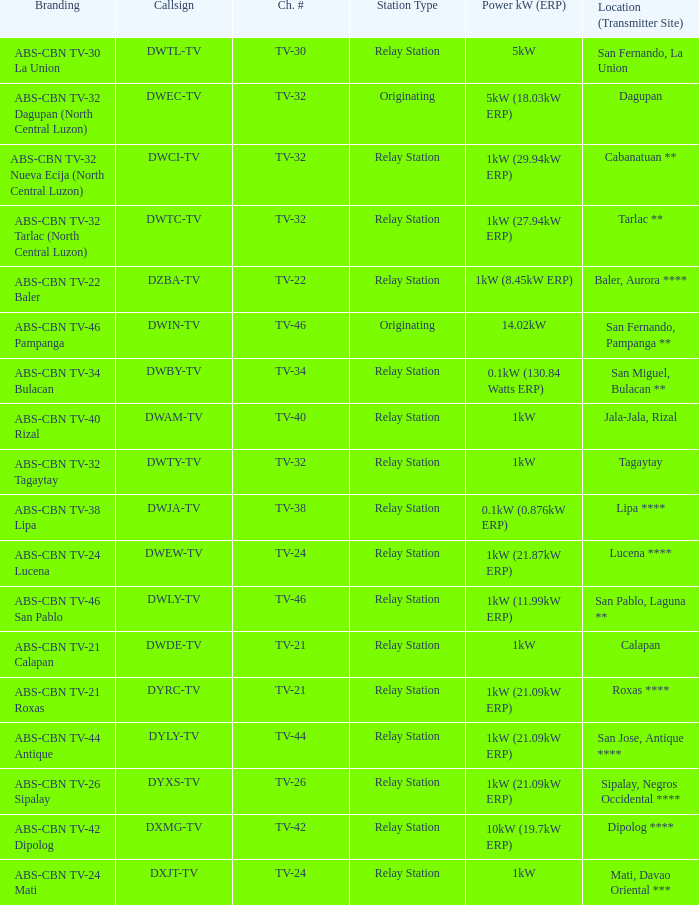What is the brand identity of the callsign dwci-tv? ABS-CBN TV-32 Nueva Ecija (North Central Luzon). 